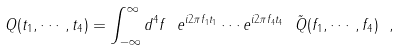<formula> <loc_0><loc_0><loc_500><loc_500>Q ( t _ { 1 } , \cdots , t _ { 4 } ) = \int _ { - \infty } ^ { \infty } d ^ { 4 } f \ e ^ { i 2 \pi f _ { 1 } t _ { 1 } } \cdots e ^ { i 2 \pi f _ { 4 } t _ { 4 } } \ \tilde { Q } ( f _ { 1 } , \cdots , f _ { 4 } ) \ ,</formula> 